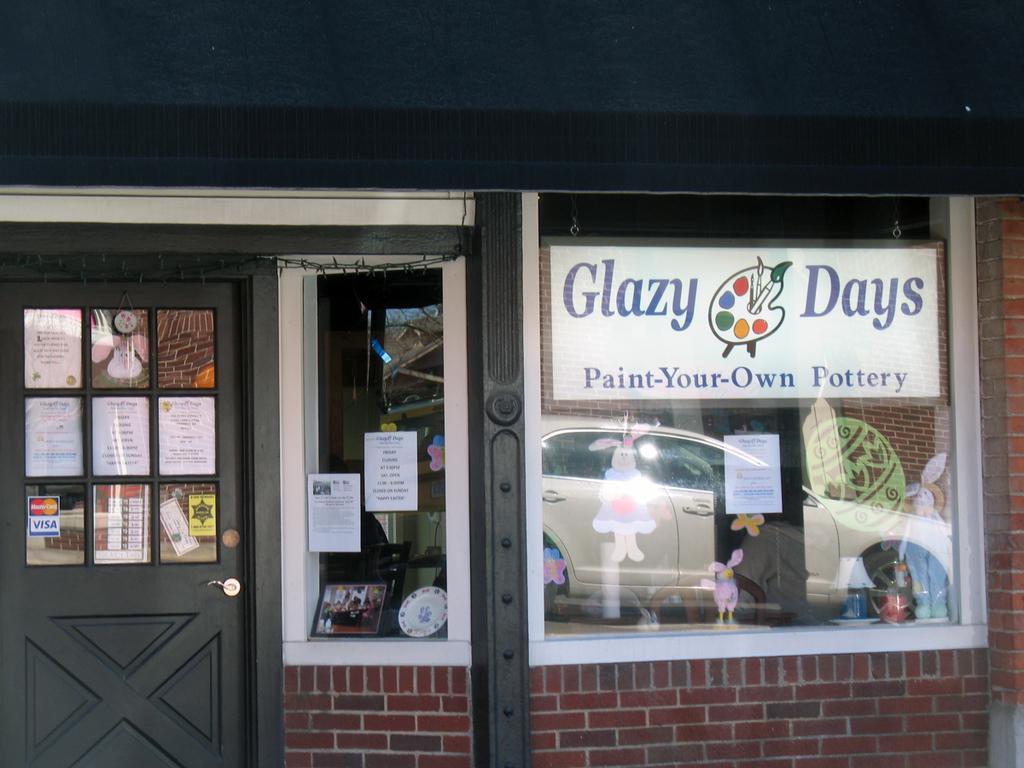Can you describe this image briefly? In this picture we can see a wall, door, posters, stickers, glass windows and some objects, from glass windows we can see a vehicle. 